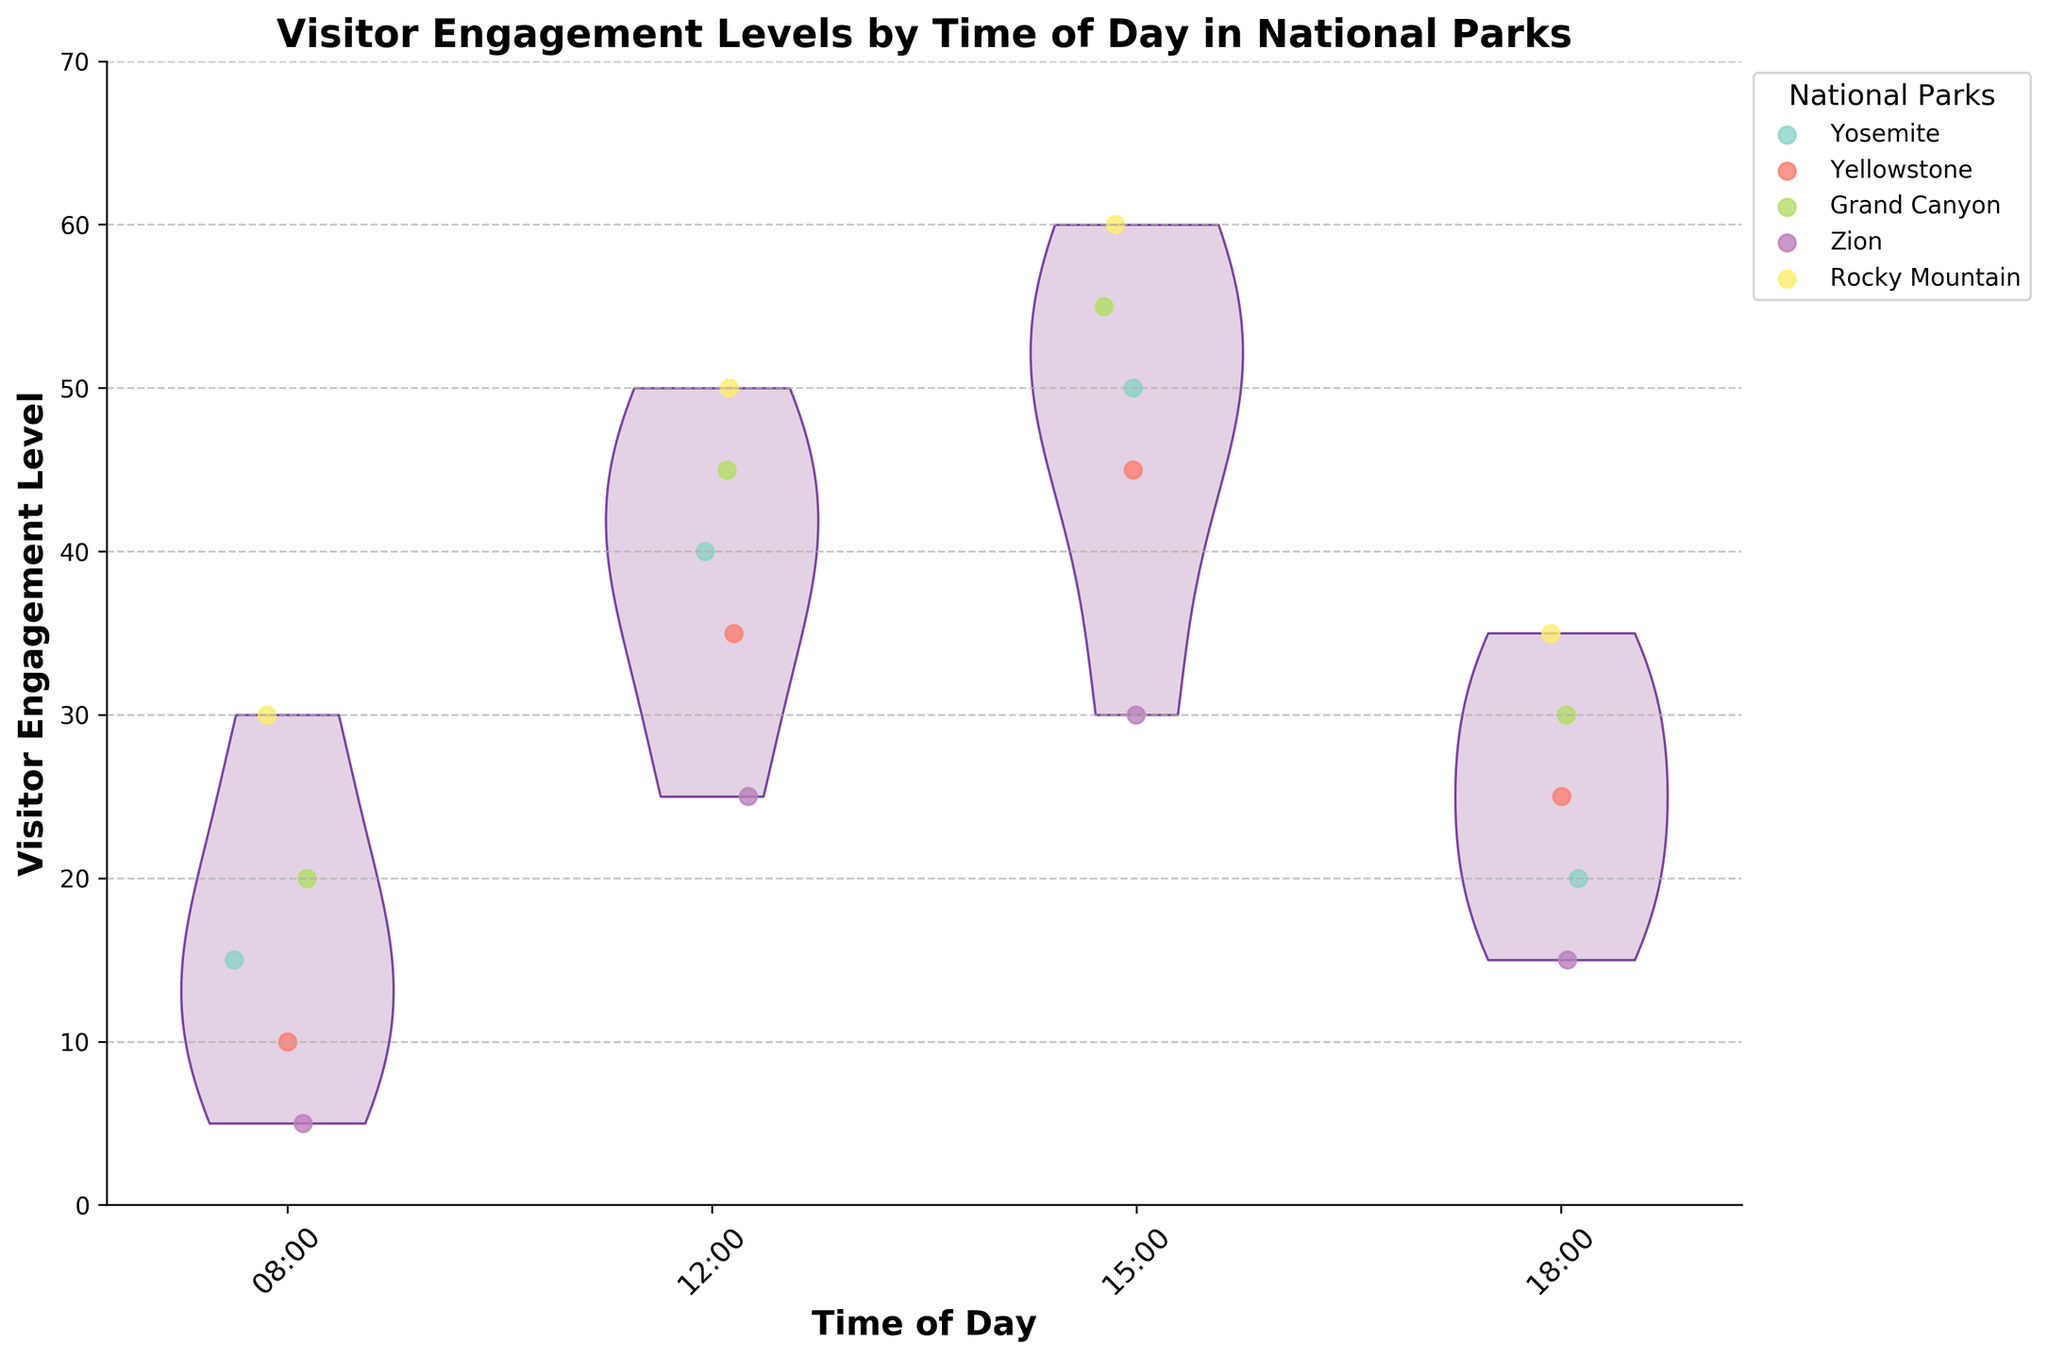What is the title of the figure? The title of the figure is usually located at the top center and is meant to describe the main subject of the plot. It reads "Visitor Engagement Levels by Time of Day in National Parks."
Answer: Visitor Engagement Levels by Time of Day in National Parks What are the labels on the x-axis? The x-axis labels represent different times of day when visitor engagement levels were recorded. They include "08:00", "12:00", "15:00", and "18:00."
Answer: 08:00, 12:00, 15:00, 18:00 What does the y-axis represent? The y-axis denotes the "Visitor Engagement Level," which is likely measured on a numerical scale to quantify how engaged visitors were.
Answer: Visitor Engagement Level Which national park showed the highest median visitor engagement level? In a violin plot, the density of data points often indicates central tendency. The Grand Canyon shows the highest engagement levels around the middle of the data distribution, visible from the plot shape and data points' locations.
Answer: Grand Canyon At what time of day do the visitor engagement levels show the most spread? The spread or variability in visitor engagement levels is highest around 15:00, as indicated by the violin plot's width and the dispersion of scattered data points.
Answer: 15:00 How does visitor engagement level at 12:00 compare to 18:00 for Rocky Mountain? The scatter points indicate that the visitor engagement level at 12:00 (50) is higher than at 18:00 (35) for Rocky Mountain.
Answer: Higher at 12:00 What is the average visitor engagement level across all parks at 08:00? Summing up the engagement levels at 08:00 (15 + 10 + 20 + 5 + 30 = 80) and dividing by the number of parks (5) gives the average. Therefore, 80/5 = 16.
Answer: 16 Which national park has the most consistent engagement levels across different times of the day? Consistency can be understood as having little variation in the engagement levels. Yosemite shows consistent high engagement levels with relatively small variation compared to others.
Answer: Yosemite What time of day shows the highest peak in visitor engagement levels? The violin plot for 15:00 shows the highest peak in engagement levels, with the most frequent high values.
Answer: 15:00 Compare the visitor engagement at 08:00 and 12:00. Which time shows a higher engagement overall? Combining and comparing the density and height of the violins at 08:00 and 12:00, 12:00 shows higher overall engagement with higher end values.
Answer: 12:00 